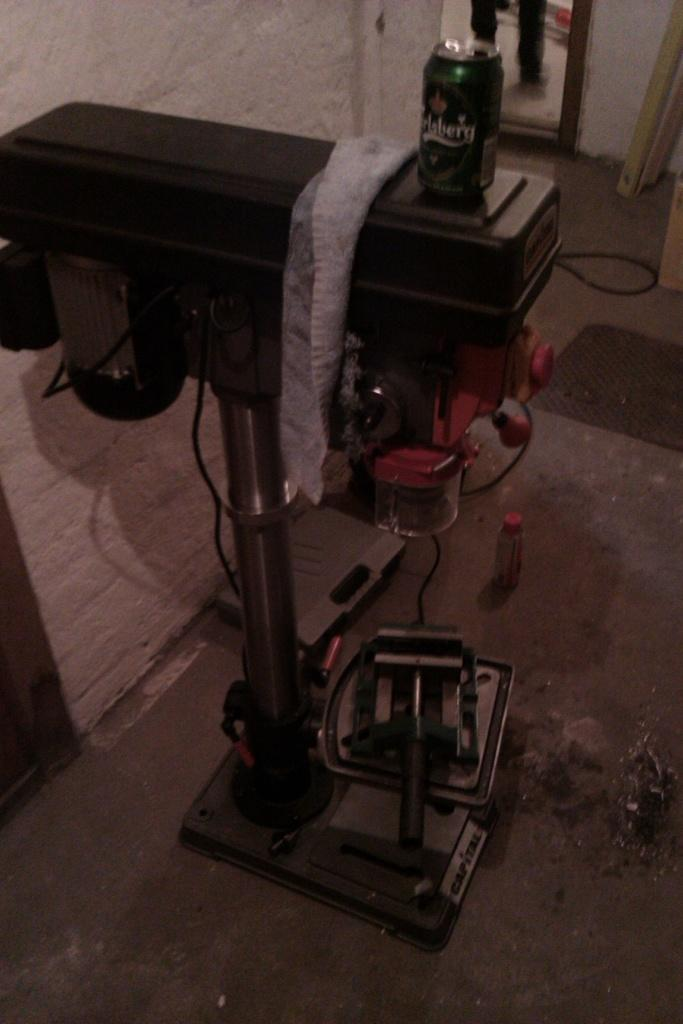Provide a one-sentence caption for the provided image. A can with a word on it that ends in a g is on a black surface. 